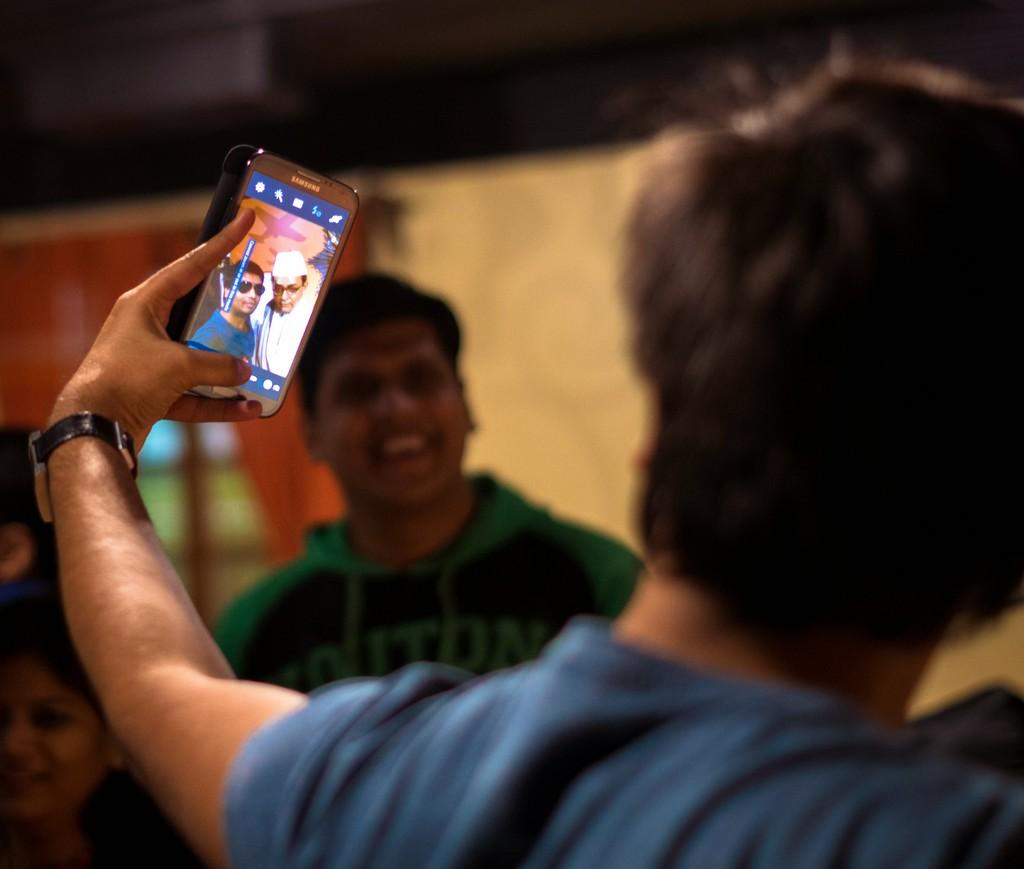Who is the main subject in the image? There is a man in the image. What is the man doing in the image? The man is standing and taking a selfie. What is the man holding in the image? The man is holding a mobile. What is the man's facial expression in the image? The man is smiling in the image. What type of lock can be seen on the frame in the image? There is no lock or frame present in the image; it features a man taking a selfie. 